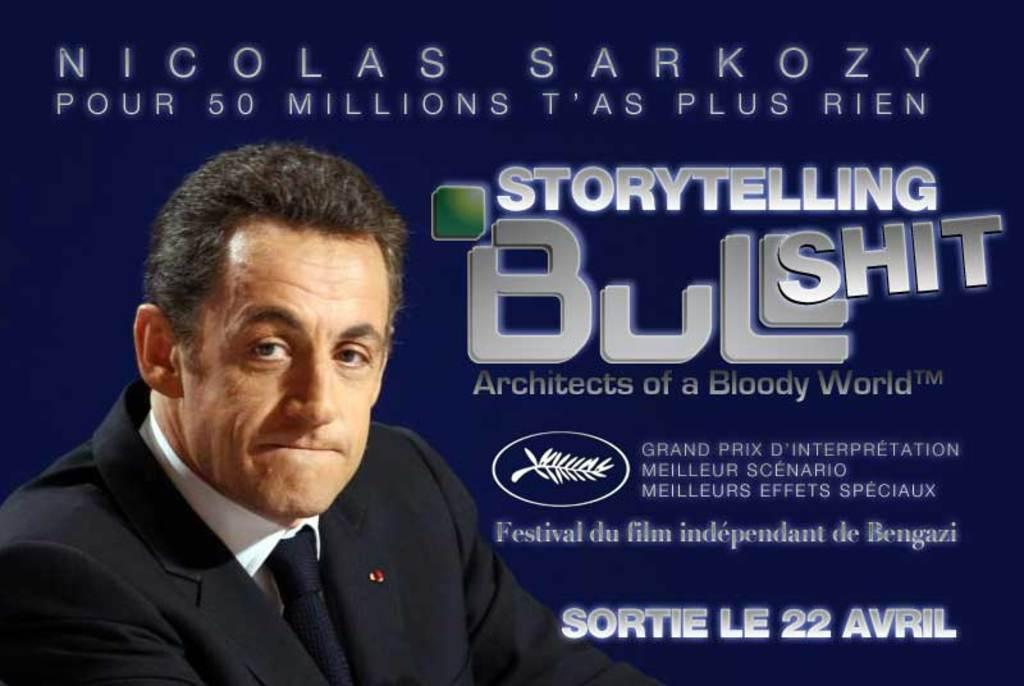What is present in the image that features a design or message? There is a poster in the image. What can be seen on the poster? There is a person depicted on the poster, along with logos and text. What type of yarn is being used to create the mitten depicted on the poster? There is no mitten depicted on the poster; it features a person, logos, and text. 